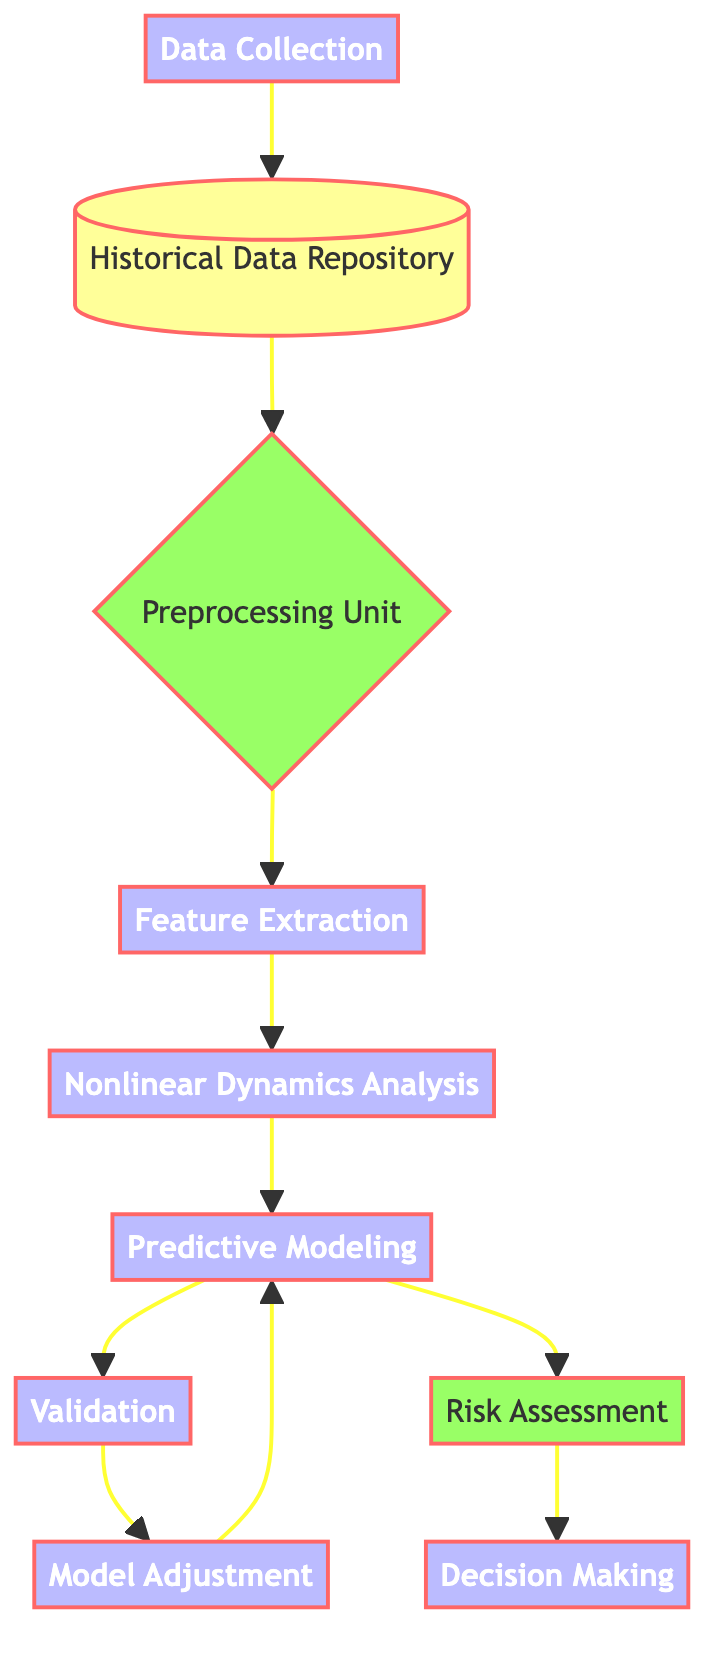What's the first node in the diagram? The diagram starts with the "Data Collection" node, which is the entry point of the process flow.
Answer: Data Collection How many total nodes are present in the diagram? There are ten nodes in total, which include all the key processes and storage points of the flow.
Answer: Ten What is the output of the "Predictive Modeling" node? The "Predictive Modeling" node produces two outputs: "Validation" and "Risk Assessment."
Answer: Validation, Risk Assessment What follows "Nonlinear Dynamics Analysis" in the flow? The "Predictive Modeling" node directly follows "Nonlinear Dynamics Analysis," indicating the next step in the process.
Answer: Predictive Modeling What is the connection between the "Validation" and "Model Adjustment" nodes? The "Validation" node leads to "Model Adjustment," which refines the models based on validation results. This creates a feedback loop as "Model Adjustment" points back to "Predictive Modeling."
Answer: Feedback loop What is the final step in the process flow? The final node in the process is "Decision Making," where insights from the analysis inform strategic financial decisions.
Answer: Decision Making Which node stores the past financial data? The node responsible for storing past financial data is labeled "Historical Data Repository."
Answer: Historical Data Repository What is the role of the "Preprocessing Unit" in the diagram? The "Preprocessing Unit" cleans and normalizes the data before it is used for further analysis, acting as a crucial step in preparing data for the next phase.
Answer: Cleaning and normalizing data What comes after "Feature Extraction"? The node immediately following "Feature Extraction" is "Nonlinear Dynamics Analysis," signifying the transition to applying chaos theory principles.
Answer: Nonlinear Dynamics Analysis 